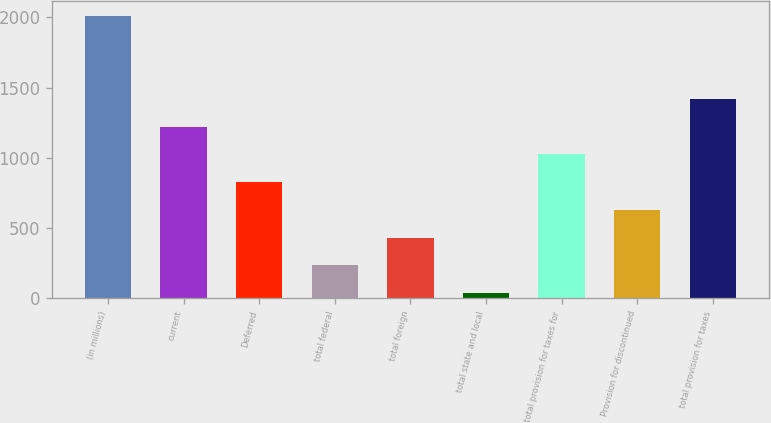<chart> <loc_0><loc_0><loc_500><loc_500><bar_chart><fcel>(in millions)<fcel>current<fcel>Deferred<fcel>total federal<fcel>total foreign<fcel>total state and local<fcel>total provision for taxes for<fcel>Provision for discontinued<fcel>total provision for taxes<nl><fcel>2014<fcel>1223.2<fcel>827.8<fcel>234.7<fcel>432.4<fcel>37<fcel>1025.5<fcel>630.1<fcel>1420.9<nl></chart> 